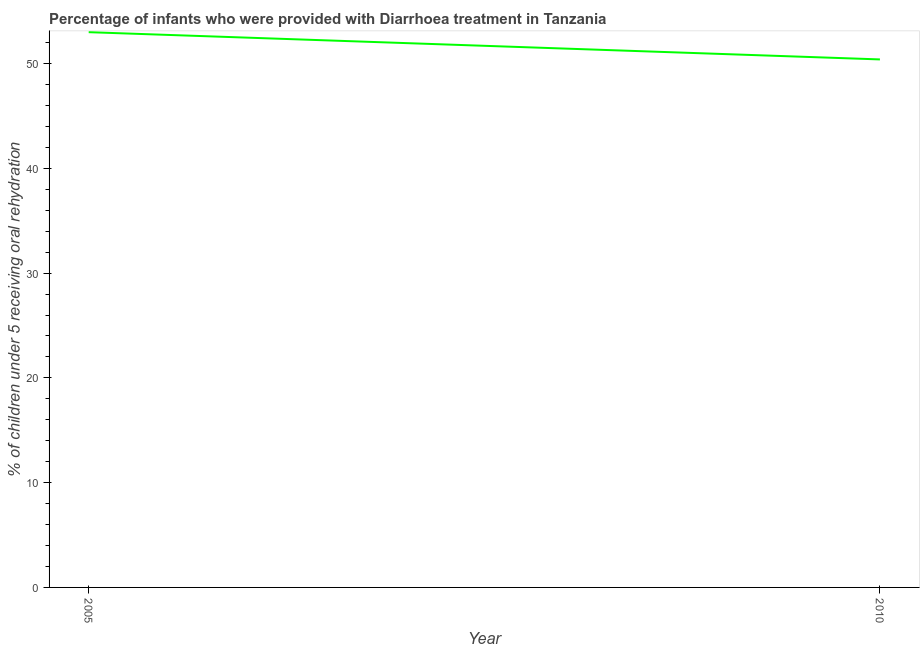What is the percentage of children who were provided with treatment diarrhoea in 2005?
Provide a short and direct response. 53. Across all years, what is the maximum percentage of children who were provided with treatment diarrhoea?
Ensure brevity in your answer.  53. Across all years, what is the minimum percentage of children who were provided with treatment diarrhoea?
Your answer should be very brief. 50.4. In which year was the percentage of children who were provided with treatment diarrhoea maximum?
Provide a succinct answer. 2005. What is the sum of the percentage of children who were provided with treatment diarrhoea?
Your answer should be compact. 103.4. What is the difference between the percentage of children who were provided with treatment diarrhoea in 2005 and 2010?
Ensure brevity in your answer.  2.6. What is the average percentage of children who were provided with treatment diarrhoea per year?
Offer a very short reply. 51.7. What is the median percentage of children who were provided with treatment diarrhoea?
Offer a very short reply. 51.7. In how many years, is the percentage of children who were provided with treatment diarrhoea greater than 40 %?
Offer a very short reply. 2. Do a majority of the years between 2010 and 2005 (inclusive) have percentage of children who were provided with treatment diarrhoea greater than 28 %?
Your answer should be compact. No. What is the ratio of the percentage of children who were provided with treatment diarrhoea in 2005 to that in 2010?
Your answer should be very brief. 1.05. Is the percentage of children who were provided with treatment diarrhoea in 2005 less than that in 2010?
Offer a very short reply. No. Does the percentage of children who were provided with treatment diarrhoea monotonically increase over the years?
Your answer should be very brief. No. How many lines are there?
Your answer should be compact. 1. How many years are there in the graph?
Make the answer very short. 2. What is the title of the graph?
Give a very brief answer. Percentage of infants who were provided with Diarrhoea treatment in Tanzania. What is the label or title of the X-axis?
Make the answer very short. Year. What is the label or title of the Y-axis?
Offer a very short reply. % of children under 5 receiving oral rehydration. What is the % of children under 5 receiving oral rehydration of 2010?
Provide a short and direct response. 50.4. What is the difference between the % of children under 5 receiving oral rehydration in 2005 and 2010?
Ensure brevity in your answer.  2.6. What is the ratio of the % of children under 5 receiving oral rehydration in 2005 to that in 2010?
Provide a short and direct response. 1.05. 